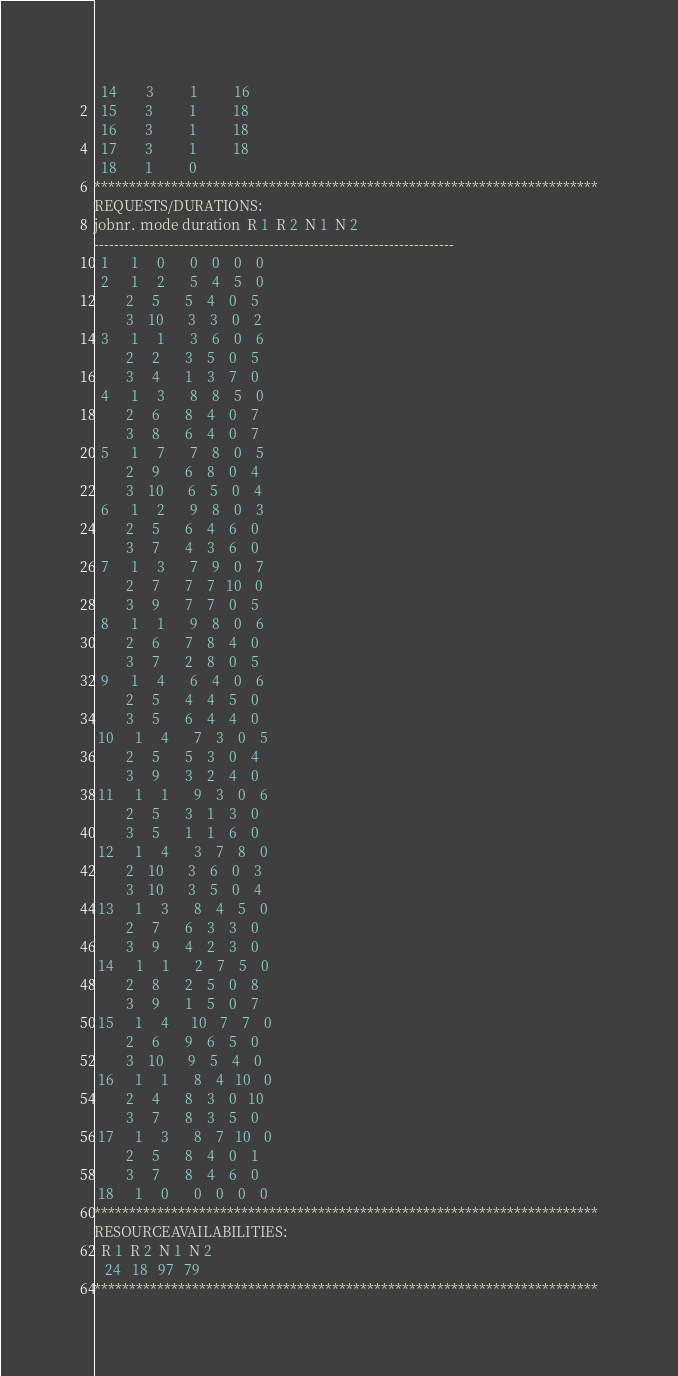Convert code to text. <code><loc_0><loc_0><loc_500><loc_500><_ObjectiveC_>  14        3          1          16
  15        3          1          18
  16        3          1          18
  17        3          1          18
  18        1          0        
************************************************************************
REQUESTS/DURATIONS:
jobnr. mode duration  R 1  R 2  N 1  N 2
------------------------------------------------------------------------
  1      1     0       0    0    0    0
  2      1     2       5    4    5    0
         2     5       5    4    0    5
         3    10       3    3    0    2
  3      1     1       3    6    0    6
         2     2       3    5    0    5
         3     4       1    3    7    0
  4      1     3       8    8    5    0
         2     6       8    4    0    7
         3     8       6    4    0    7
  5      1     7       7    8    0    5
         2     9       6    8    0    4
         3    10       6    5    0    4
  6      1     2       9    8    0    3
         2     5       6    4    6    0
         3     7       4    3    6    0
  7      1     3       7    9    0    7
         2     7       7    7   10    0
         3     9       7    7    0    5
  8      1     1       9    8    0    6
         2     6       7    8    4    0
         3     7       2    8    0    5
  9      1     4       6    4    0    6
         2     5       4    4    5    0
         3     5       6    4    4    0
 10      1     4       7    3    0    5
         2     5       5    3    0    4
         3     9       3    2    4    0
 11      1     1       9    3    0    6
         2     5       3    1    3    0
         3     5       1    1    6    0
 12      1     4       3    7    8    0
         2    10       3    6    0    3
         3    10       3    5    0    4
 13      1     3       8    4    5    0
         2     7       6    3    3    0
         3     9       4    2    3    0
 14      1     1       2    7    5    0
         2     8       2    5    0    8
         3     9       1    5    0    7
 15      1     4      10    7    7    0
         2     6       9    6    5    0
         3    10       9    5    4    0
 16      1     1       8    4   10    0
         2     4       8    3    0   10
         3     7       8    3    5    0
 17      1     3       8    7   10    0
         2     5       8    4    0    1
         3     7       8    4    6    0
 18      1     0       0    0    0    0
************************************************************************
RESOURCEAVAILABILITIES:
  R 1  R 2  N 1  N 2
   24   18   97   79
************************************************************************
</code> 